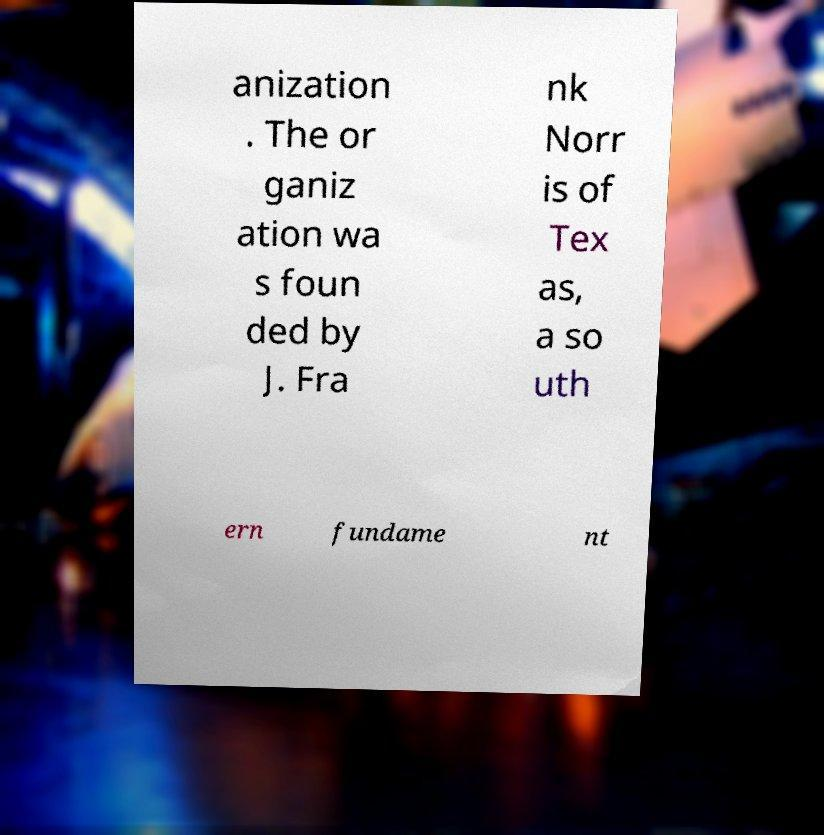Can you read and provide the text displayed in the image?This photo seems to have some interesting text. Can you extract and type it out for me? anization . The or ganiz ation wa s foun ded by J. Fra nk Norr is of Tex as, a so uth ern fundame nt 